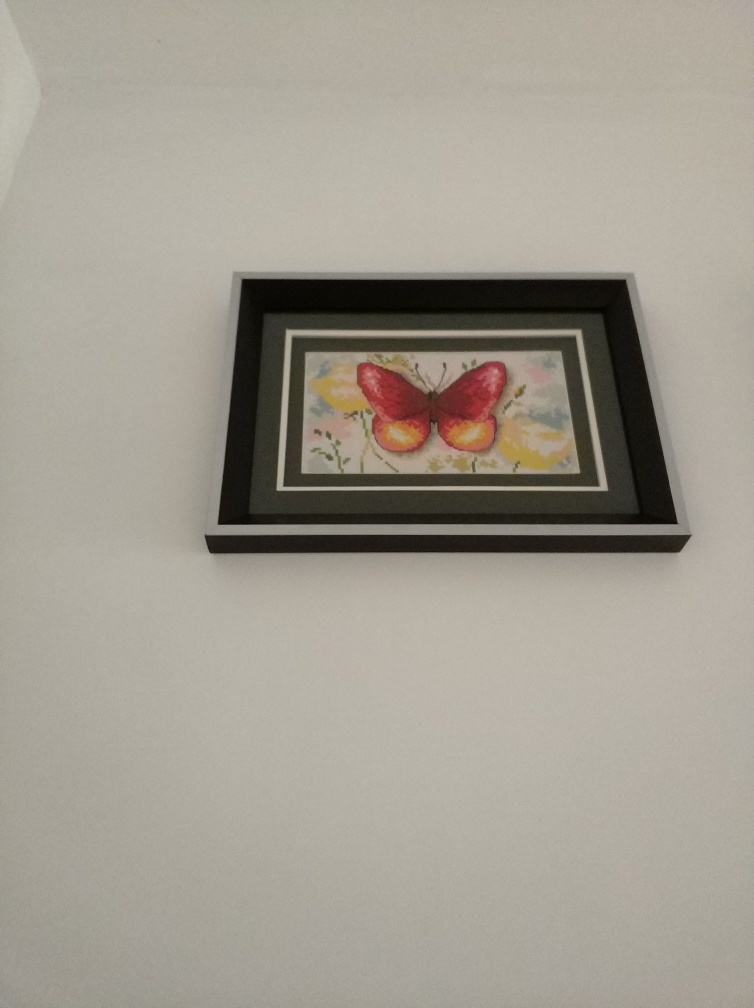Does this image convey any symbolic meaning? Butterflies are often associated with transformation, hope, and the beauty of nature. The solitary butterfly in this piece, set against the delicate botanical elements, may suggest themes of individual growth or the fleeting nature of beauty. It's a simple yet evocative representation that can inspire viewers to find their own interpretations. 